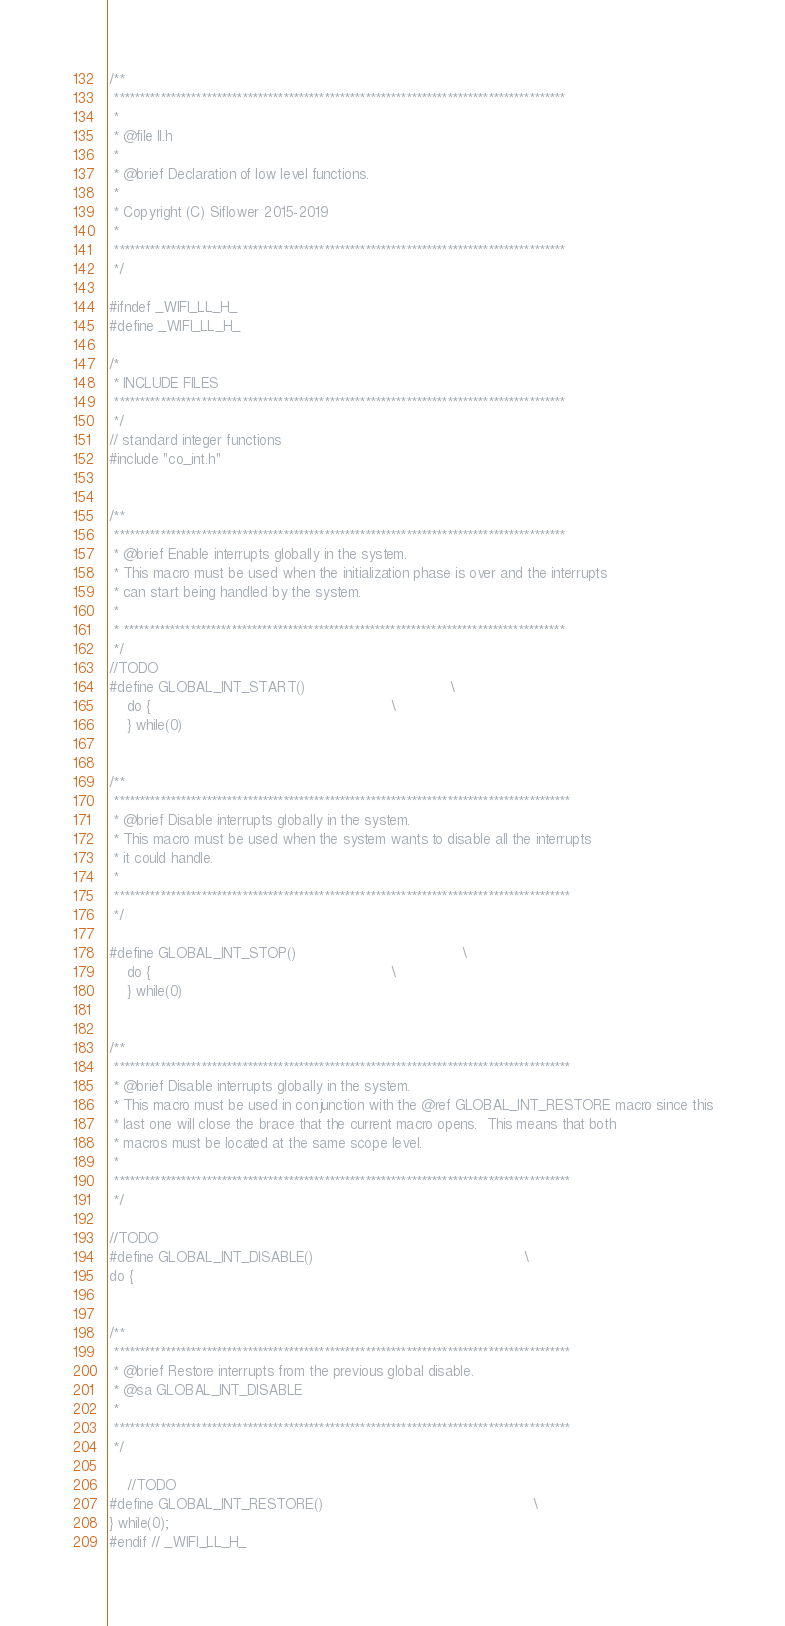Convert code to text. <code><loc_0><loc_0><loc_500><loc_500><_C_>/**
 ****************************************************************************************
 *
 * @file ll.h
 *
 * @brief Declaration of low level functions.
 *
 * Copyright (C) Siflower 2015-2019
 *
 ****************************************************************************************
 */

#ifndef _WIFI_LL_H_
#define _WIFI_LL_H_

/*
 * INCLUDE FILES
 ****************************************************************************************
 */
// standard integer functions
#include "co_int.h"


/**
 ****************************************************************************************
 * @brief Enable interrupts globally in the system.
 * This macro must be used when the initialization phase is over and the interrupts
 * can start being handled by the system.
 *
 * **************************************************************************************
 */
//TODO
#define GLOBAL_INT_START()                                 \
    do {                                                       \
    } while(0)


/**
 *****************************************************************************************
 * @brief Disable interrupts globally in the system.
 * This macro must be used when the system wants to disable all the interrupts
 * it could handle.
 *
 *****************************************************************************************
 */

#define GLOBAL_INT_STOP()                                      \
    do {                                                       \
    } while(0)


/**
 *****************************************************************************************
 * @brief Disable interrupts globally in the system.
 * This macro must be used in conjunction with the @ref GLOBAL_INT_RESTORE macro since this
 * last one will close the brace that the current macro opens.  This means that both
 * macros must be located at the same scope level.
 *
 *****************************************************************************************
 */

//TODO
#define GLOBAL_INT_DISABLE()                                                \
do {


/**
 *****************************************************************************************
 * @brief Restore interrupts from the previous global disable.
 * @sa GLOBAL_INT_DISABLE
 *
 *****************************************************************************************
 */

    //TODO
#define GLOBAL_INT_RESTORE()                                                \
} while(0);
#endif // _WIFI_LL_H_
</code> 